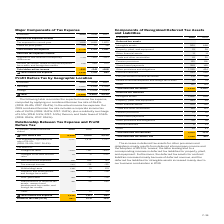According to Sap Ag's financial document, What was the profit before tax in 2019? According to the financial document, 4,596 (in millions). The relevant text states: "Profit before tax 4,596 5,600 5,029..." Also, In which years was the Relationship Between Tax Expense and Profit Before Tax analyzed? The document contains multiple relevant values: 2019, 2018, 2017. From the document: "€ millions 2019 2018 2017 € millions 2019 2018 2017 € millions 2019 2018 2017..." Also, What was the applicable tax rate in 2018? According to the financial document, 26.4%. The relevant text states: "Tax expense at applicable tax rate of 26.4% (2018: 26.4%; 2017: 26.4%)..." Additionally, In which year was profit before tax the largest? According to the financial document, 2018. The relevant text states: "€ millions 2019 2018 2017..." Also, can you calculate: What was the change in Other in 2019 from 2018? I cannot find a specific answer to this question in the financial document. Also, can you calculate: What was the percentage change in Other in 2019 from 2018? I cannot find a specific answer to this question in the financial document. 